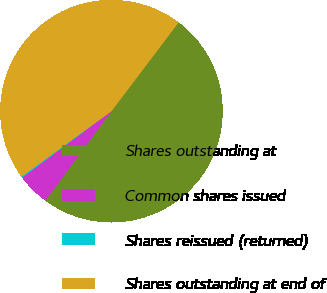Convert chart. <chart><loc_0><loc_0><loc_500><loc_500><pie_chart><fcel>Shares outstanding at<fcel>Common shares issued<fcel>Shares reissued (returned)<fcel>Shares outstanding at end of<nl><fcel>49.82%<fcel>4.7%<fcel>0.18%<fcel>45.3%<nl></chart> 